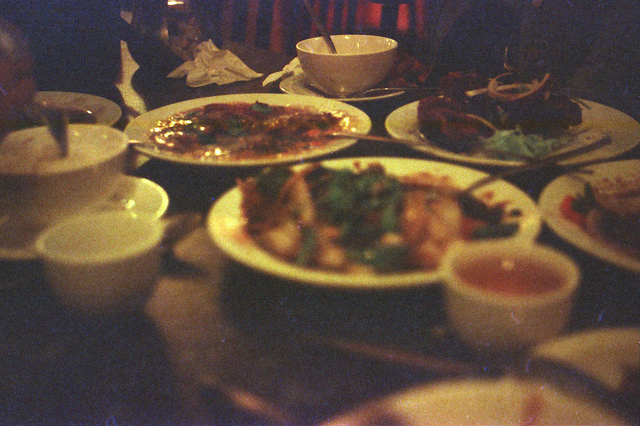<image>Have any of these foods been eaten? I don't know if any of these foods have been eaten. The image is ambiguous. Have any of these foods been eaten? It is not clear whether any of these foods have been eaten. Some of them might have been eaten while others might not have been eaten. 